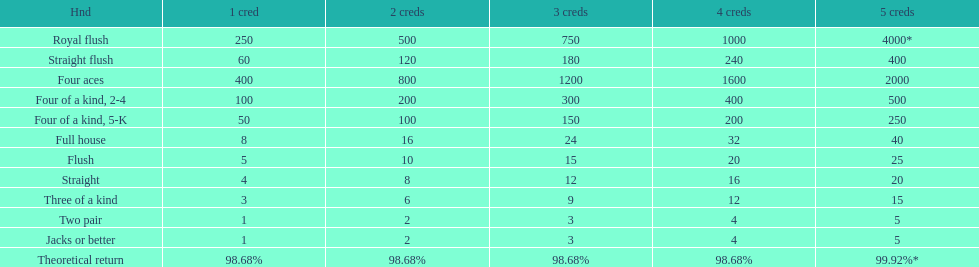After winning on four credits with a full house, what is your payout? 32. 